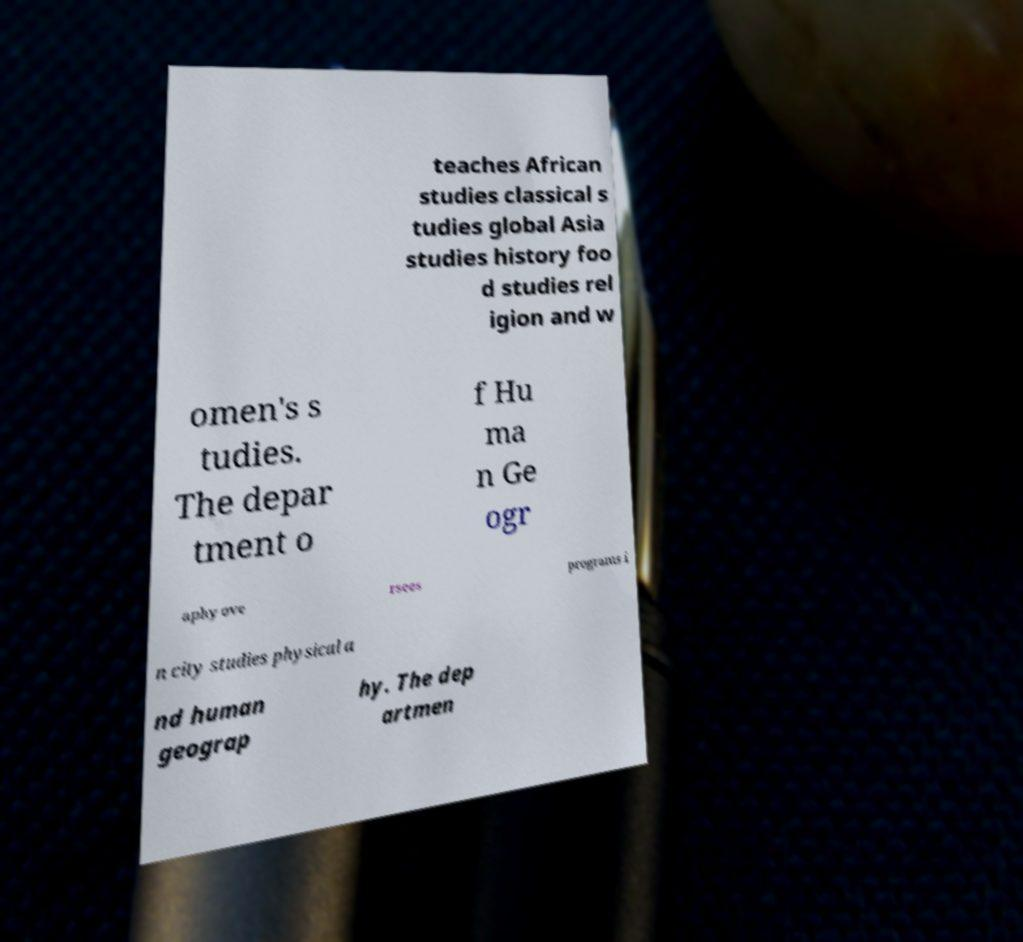For documentation purposes, I need the text within this image transcribed. Could you provide that? teaches African studies classical s tudies global Asia studies history foo d studies rel igion and w omen's s tudies. The depar tment o f Hu ma n Ge ogr aphy ove rsees programs i n city studies physical a nd human geograp hy. The dep artmen 